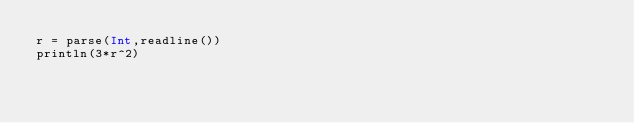Convert code to text. <code><loc_0><loc_0><loc_500><loc_500><_Julia_>r = parse(Int,readline())
println(3*r^2)</code> 